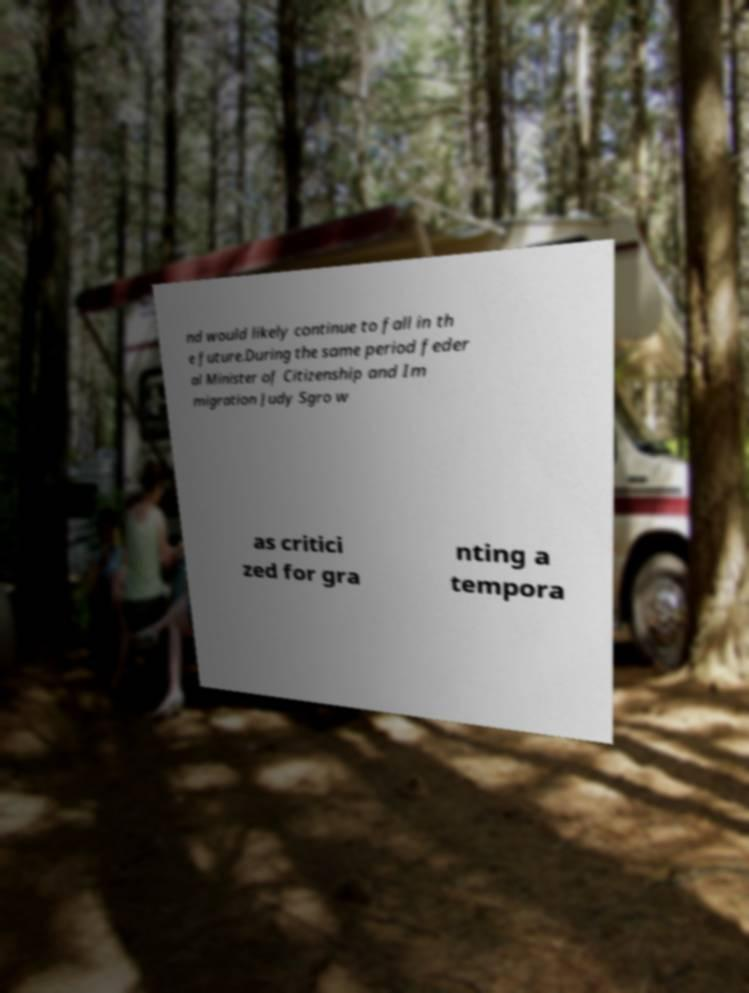Please identify and transcribe the text found in this image. nd would likely continue to fall in th e future.During the same period feder al Minister of Citizenship and Im migration Judy Sgro w as critici zed for gra nting a tempora 